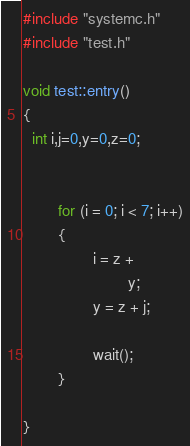Convert code to text. <code><loc_0><loc_0><loc_500><loc_500><_C++_>
#include "systemc.h"
#include "test.h"

void test::entry() 
{
  int i,j=0,y=0,z=0;
 
 
        for (i = 0; i < 7; i++)
        {
                i = z +
                        y;
                y = z + j;
 
                wait();
        }

}

</code> 